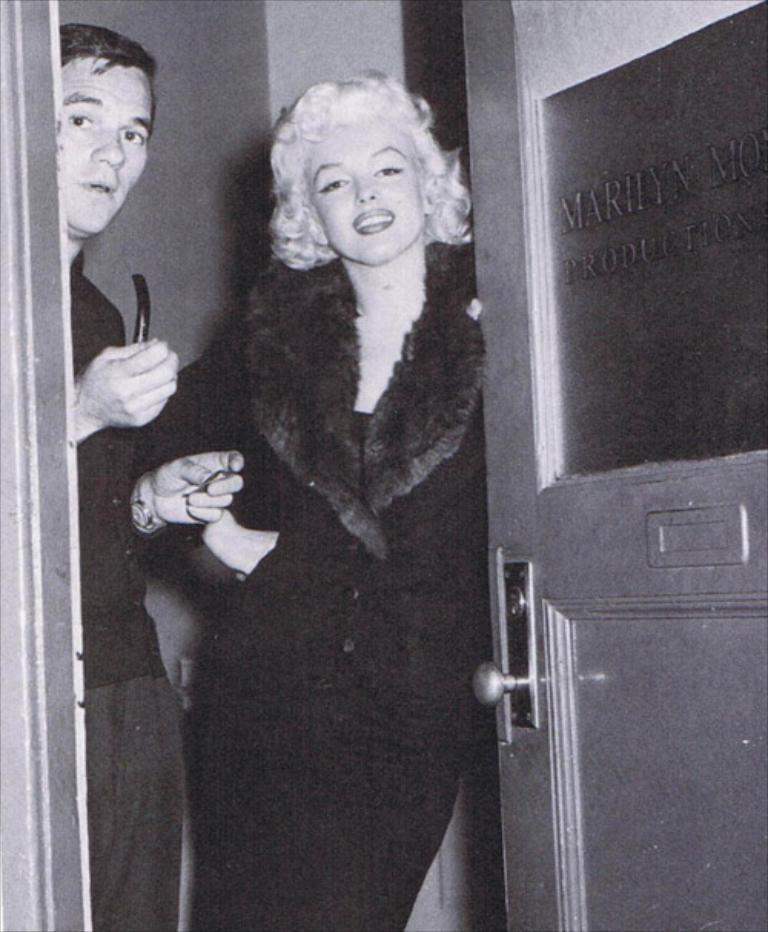In one or two sentences, can you explain what this image depicts? In this image there are two people standing. There is a door on the right side. We can see text on the door. There is a wall in the background. 